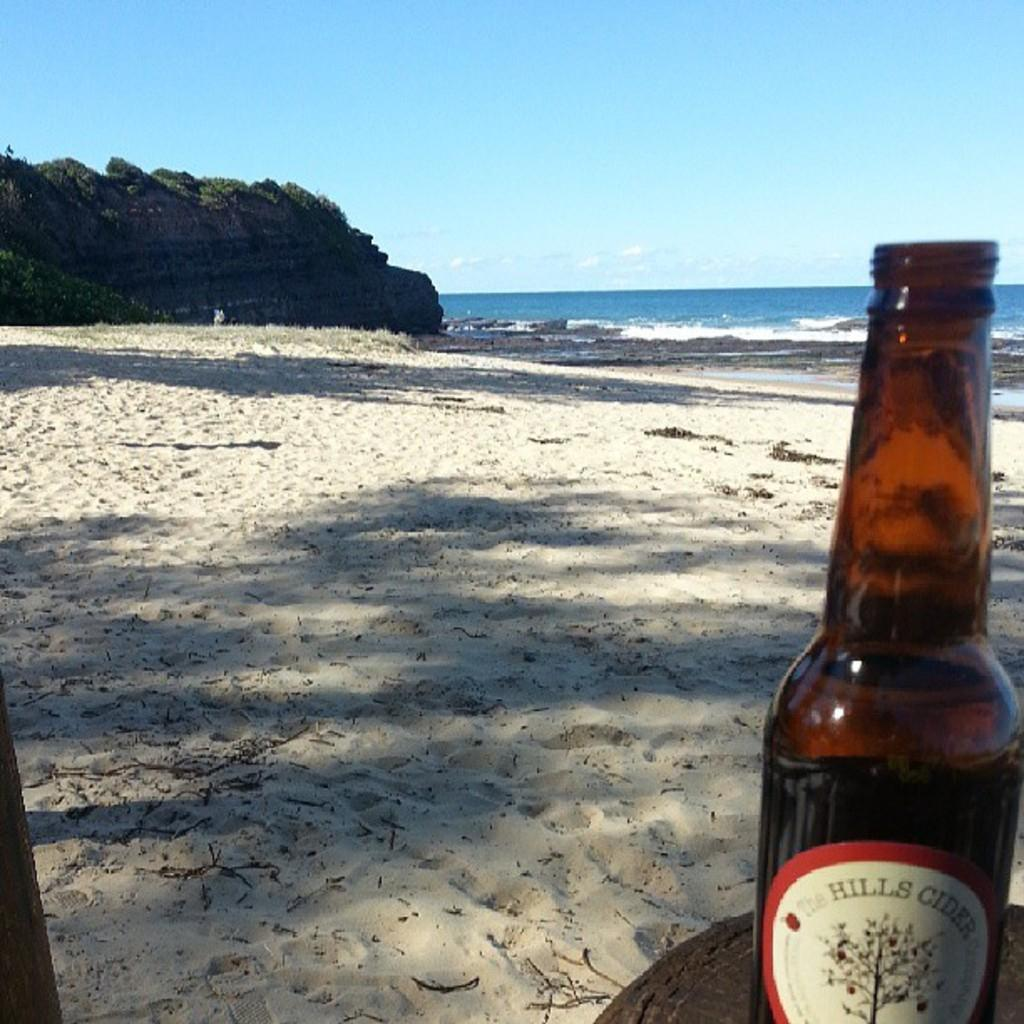<image>
Share a concise interpretation of the image provided. A bottle of Hills Cider on a beach. 